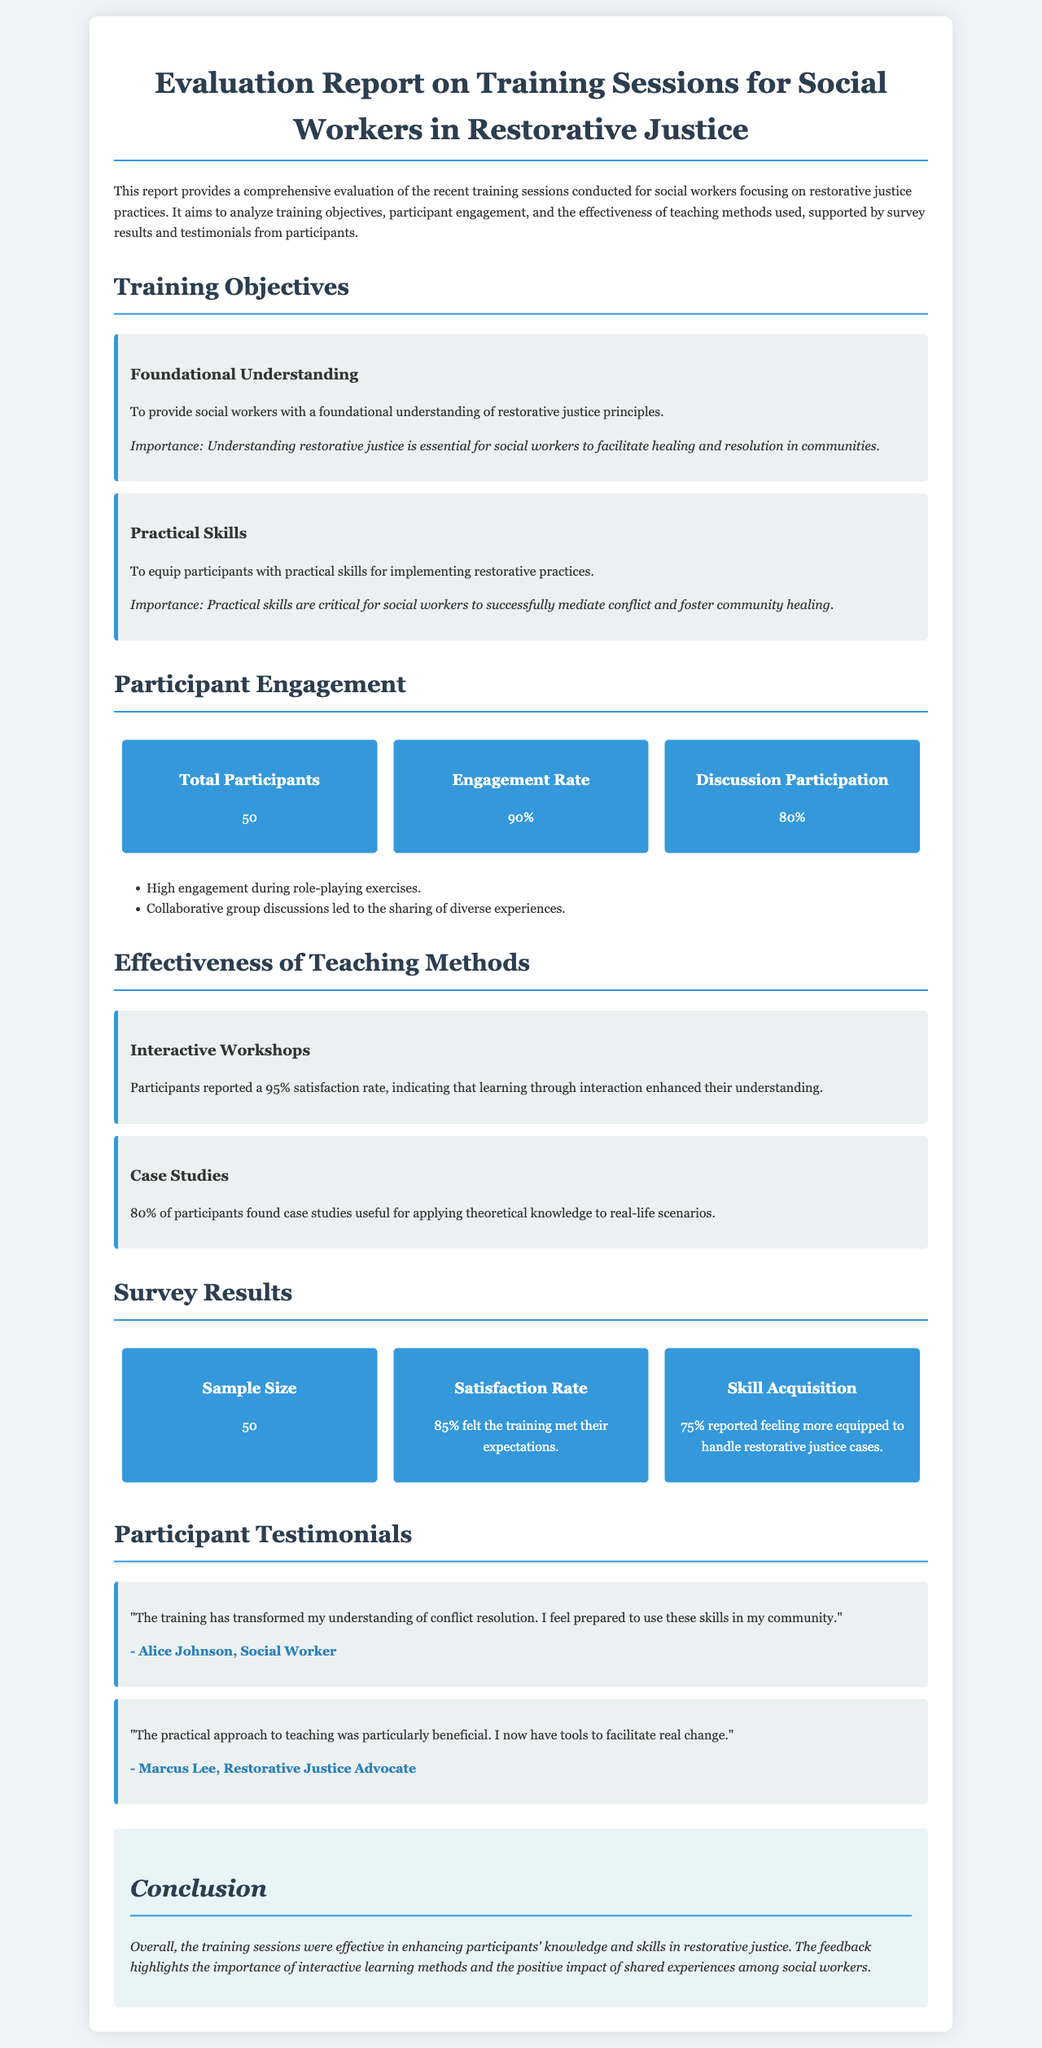What is the total number of participants? The total number of participants is stated in the statistics section of the report.
Answer: 50 What percentage of participants found the training helpful? The report mentions that 85% felt the training met their expectations.
Answer: 85% What topic did Alice Johnson mention in her testimonial? Alice Johnson highlighted her transformed understanding of conflict resolution in her testimonial.
Answer: Conflict resolution What teaching method had a 95% satisfaction rate? The effectiveness of teaching methods section indicates that interactive workshops had a 95% satisfaction rate.
Answer: Interactive Workshops What percentage of participants reported feeling better equipped for restorative justice cases? 75% of surveyed participants indicated improved confidence in handling restorative justice cases.
Answer: 75% Which type of method was specifically highlighted for enhancing understanding? The report emphasizes the importance of interactive learning methods for enhancing participant understanding.
Answer: Interactive learning methods What was the engagement rate during the training sessions? The engagement rate is provided in the statistics overview of the report.
Answer: 90% Which author provided a testimonial about practical approaches to teaching? The testimonial section attributes a statement about practical teaching to Marcus Lee.
Answer: Marcus Lee 